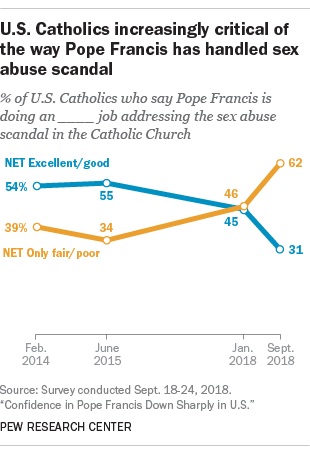Indicate a few pertinent items in this graphic. What is the peak rating for the good? The largest gap between positive and negative ratings was in the year 2018. 